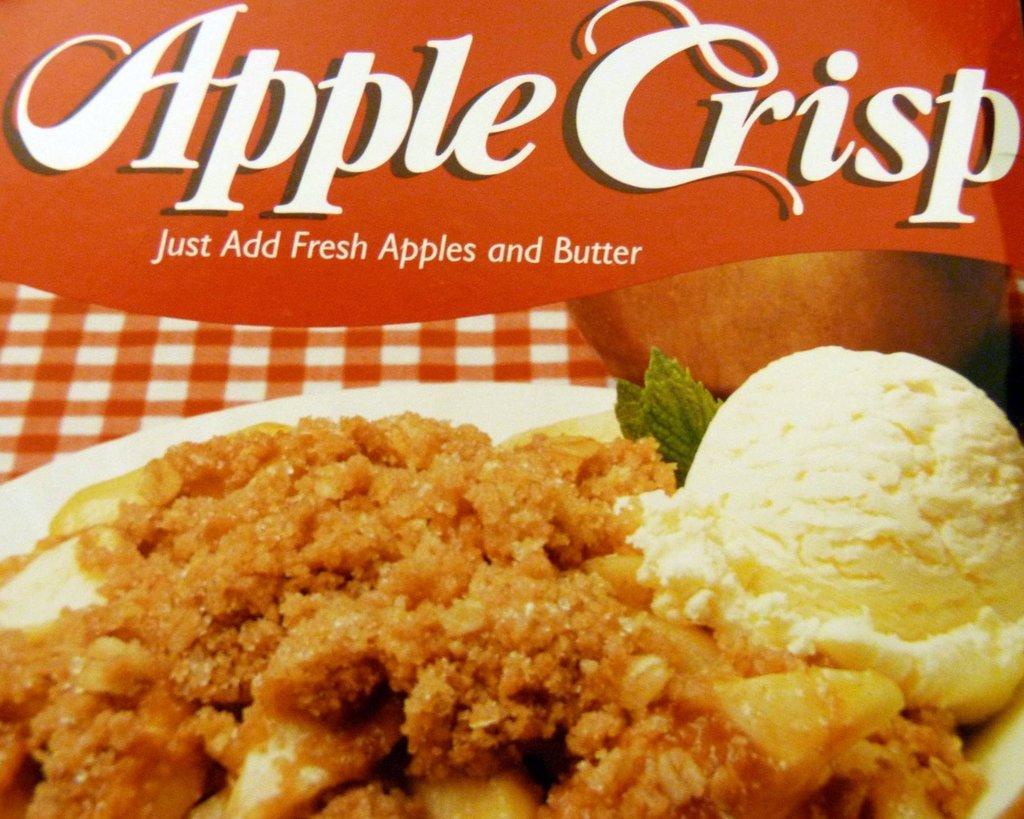What type of visual is the image? The image is a poster. What is featured on the poster? There are food items depicted in the poster. What else is present on the poster besides the food items? There is text present in the poster. Can you tell me how many beads are used to create the poster? There is no information about beads being used to create the poster, as it is a printed visual. What type of play is depicted in the poster? There is no play or any form of performance depicted in the poster; it features food items and text. 